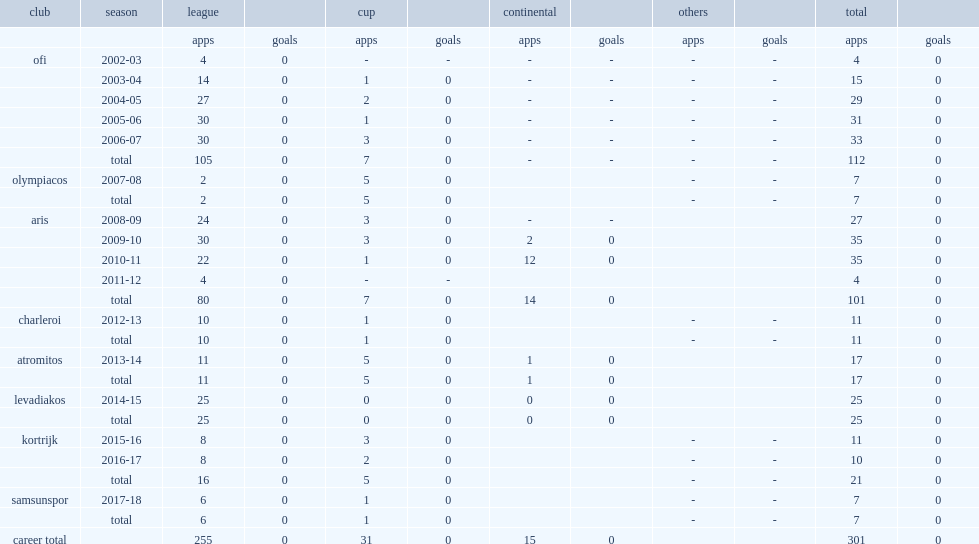Michalis sifakis played for ofi until 2007, how many matches did he participate in? 112.0. 